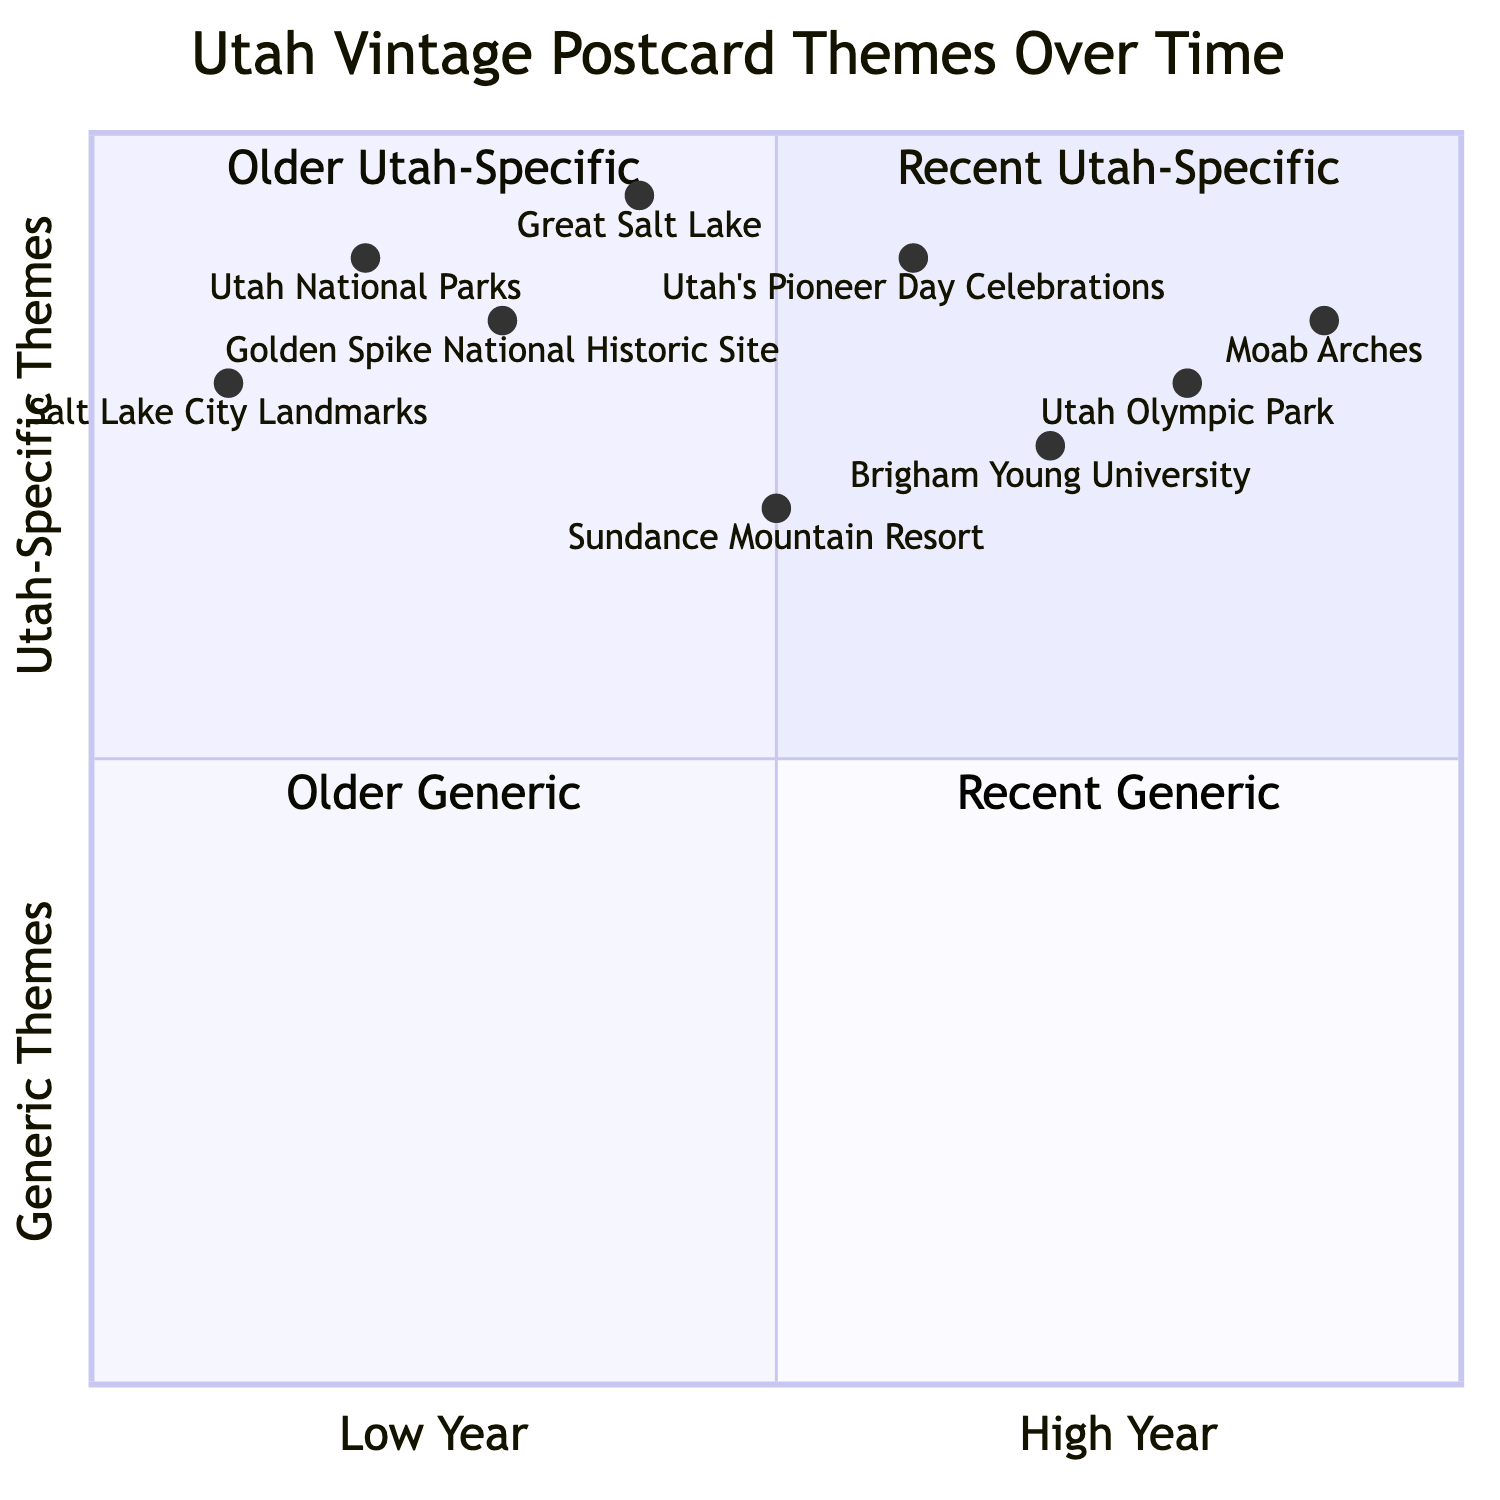What themes are categorized as "Recent Utah-Specific"? To determine this, I need to look at the quadrant where "Recent Utah-Specific" is located, which is quadrant 1. In this quadrant, the themes listed are "Utah Olympic Park" and "Moab Arches."
Answer: Utah Olympic Park, Moab Arches Which postcard from 1955 features a theme related to Utah's celebrations? The postcard from 1955 is "Utah’s Pioneer Day Celebrations." I locate the year first, then check the corresponding theme.
Answer: Utah’s Pioneer Day Celebrations How many themes are classified as "Older Generic"? I will identify the themes in quadrant 3, which represents "Older Generic" themes. There are three themes: "Great Salt Lake," "Golden Spike National Historic Site," and "Salt Lake City Landmarks." Thus, the total is three themes.
Answer: 3 What is the year of issue for the theme "Brigham Young University"? The diagram indicates that "Brigham Young University" falls in quadrant 1. I can find the specific node for this theme, which shows it was issued in 1965.
Answer: 1965 Which postcard theme was issued in 1945? To answer this, I check the list of themes and years. The theme associated with 1945 is "Sundance Mountain Resort." This information can be confirmed by looking at the year and its location in the diagram.
Answer: Sundance Mountain Resort What is the year range for the themes represented in quadrant 2? Quadrant 2, "Older Utah-Specific," includes themes issued from 1905 ("Salt Lake City Landmarks") to 1955 ("Utah’s Pioneer Day Celebrations"). Therefore, the year range is from 1905 to 1955.
Answer: 1905 to 1955 Which theme has the highest year of issue? Look for the theme located at the far right of the x-axis in the diagram. "Moab Arches" represents the highest year of issue at 1985.
Answer: Moab Arches How many themes are from the year 1976 or later? First, I identify themes from 1976 onwards. The relevant themes are "Utah Olympic Park" (1976) and "Moab Arches" (1985), thus the total is two themes when counting these years.
Answer: 2 